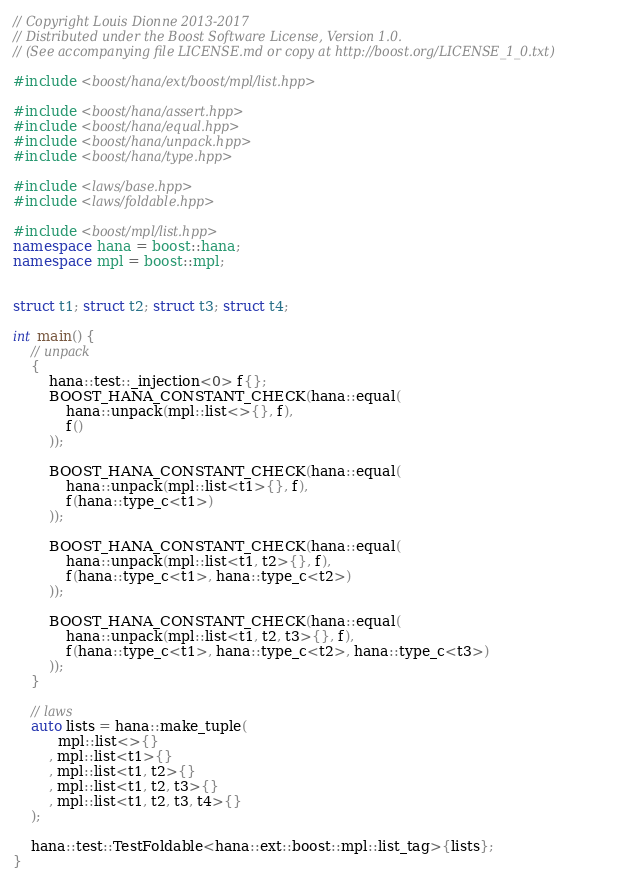<code> <loc_0><loc_0><loc_500><loc_500><_C++_>// Copyright Louis Dionne 2013-2017
// Distributed under the Boost Software License, Version 1.0.
// (See accompanying file LICENSE.md or copy at http://boost.org/LICENSE_1_0.txt)

#include <boost/hana/ext/boost/mpl/list.hpp>

#include <boost/hana/assert.hpp>
#include <boost/hana/equal.hpp>
#include <boost/hana/unpack.hpp>
#include <boost/hana/type.hpp>

#include <laws/base.hpp>
#include <laws/foldable.hpp>

#include <boost/mpl/list.hpp>
namespace hana = boost::hana;
namespace mpl = boost::mpl;


struct t1; struct t2; struct t3; struct t4;

int main() {
    // unpack
    {
        hana::test::_injection<0> f{};
        BOOST_HANA_CONSTANT_CHECK(hana::equal(
            hana::unpack(mpl::list<>{}, f),
            f()
        ));

        BOOST_HANA_CONSTANT_CHECK(hana::equal(
            hana::unpack(mpl::list<t1>{}, f),
            f(hana::type_c<t1>)
        ));

        BOOST_HANA_CONSTANT_CHECK(hana::equal(
            hana::unpack(mpl::list<t1, t2>{}, f),
            f(hana::type_c<t1>, hana::type_c<t2>)
        ));

        BOOST_HANA_CONSTANT_CHECK(hana::equal(
            hana::unpack(mpl::list<t1, t2, t3>{}, f),
            f(hana::type_c<t1>, hana::type_c<t2>, hana::type_c<t3>)
        ));
    }

    // laws
    auto lists = hana::make_tuple(
          mpl::list<>{}
        , mpl::list<t1>{}
        , mpl::list<t1, t2>{}
        , mpl::list<t1, t2, t3>{}
        , mpl::list<t1, t2, t3, t4>{}
    );

    hana::test::TestFoldable<hana::ext::boost::mpl::list_tag>{lists};
}
</code> 